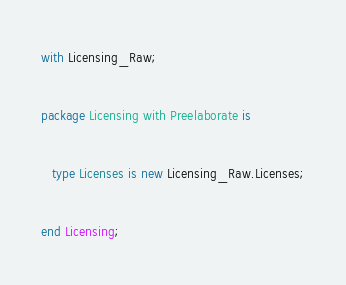Convert code to text. <code><loc_0><loc_0><loc_500><loc_500><_Ada_>with Licensing_Raw;

package Licensing with Preelaborate is

   type Licenses is new Licensing_Raw.Licenses;

end Licensing;
</code> 